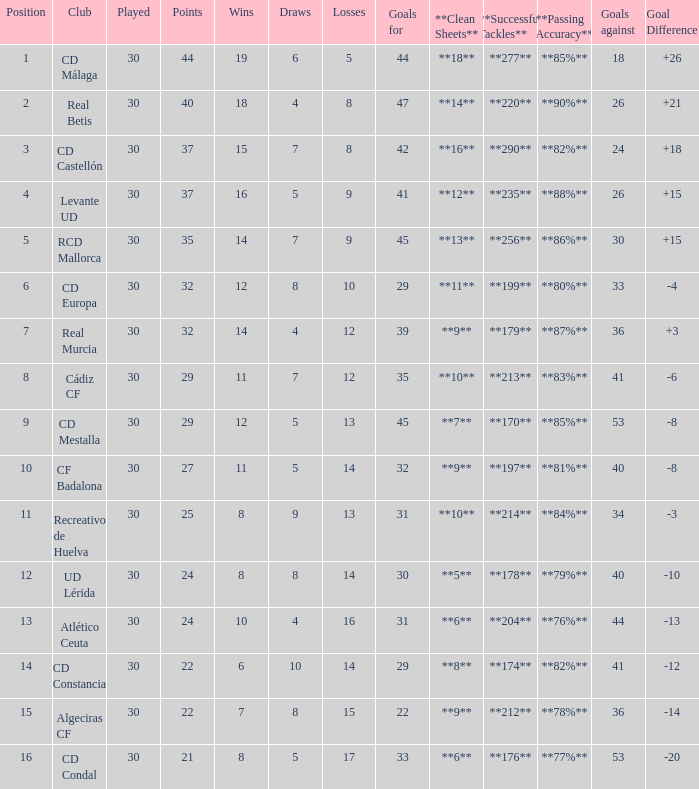What is the goals for when played is larger than 30? None. 